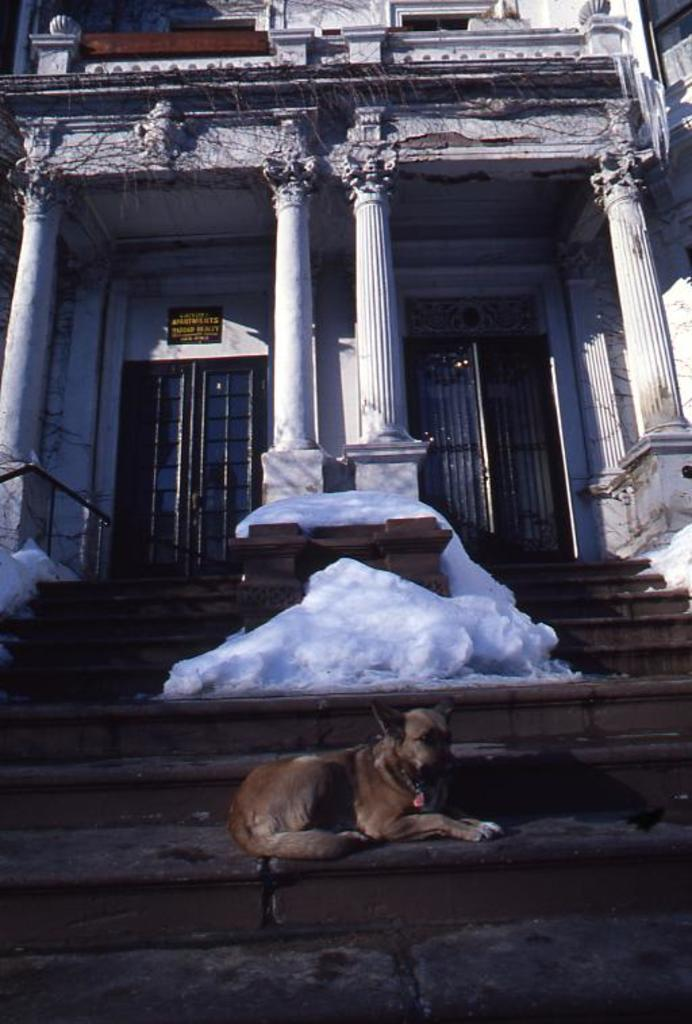What type of structure is visible in the image? There is a building in the image. What are some features of the building? The building has doors, a poster, pillars, and stairs. Can you describe the objects on the stairs? There are objects on the stairs, but their specific nature is not mentioned in the facts. What is the presence of a dog on the stairs? There is a dog on the stairs in the image. How many rings are visible on the dog's collar in the image? There is no mention of a dog's collar or rings in the image, so we cannot determine the number of rings. 